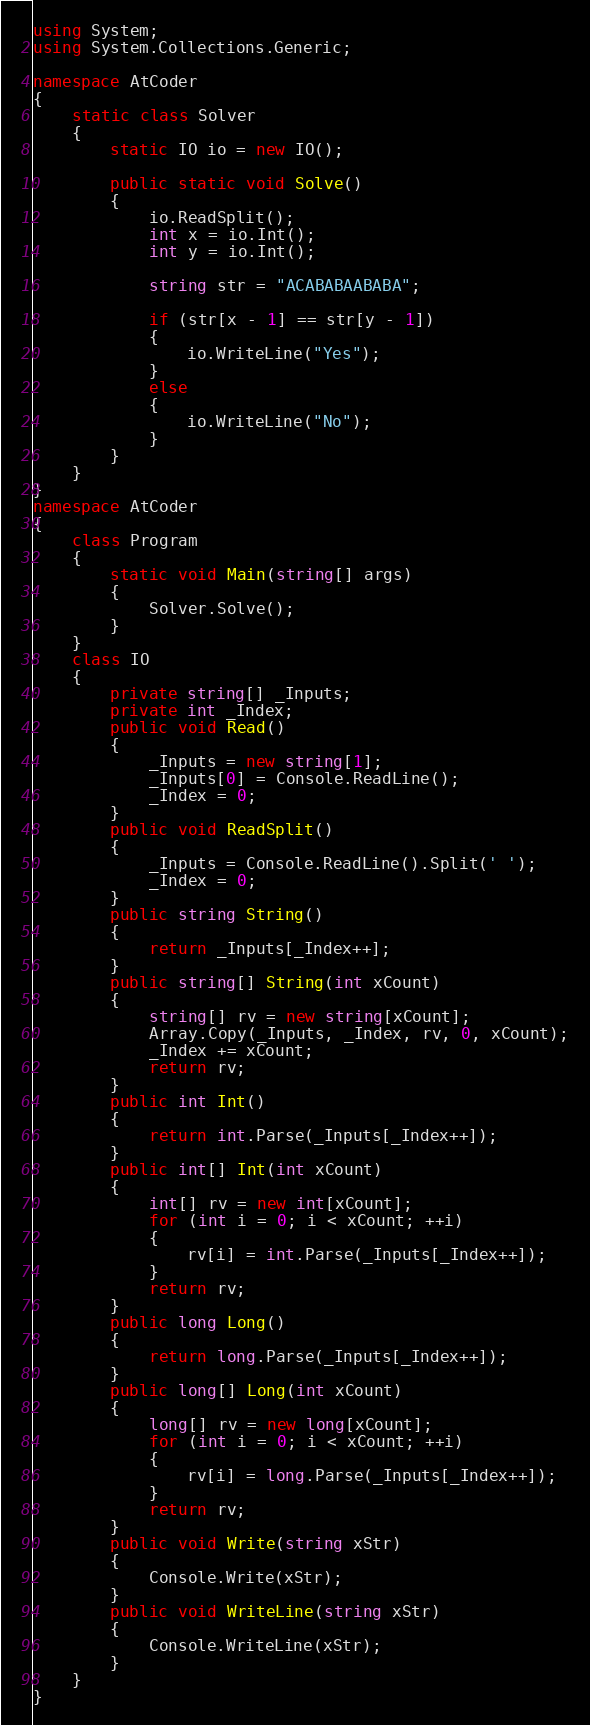<code> <loc_0><loc_0><loc_500><loc_500><_C#_>using System;
using System.Collections.Generic;

namespace AtCoder
{
    static class Solver
    {
        static IO io = new IO();

        public static void Solve()
        {
            io.ReadSplit();
            int x = io.Int();
            int y = io.Int();

            string str = "ACABABAABABA";

            if (str[x - 1] == str[y - 1])
            {
                io.WriteLine("Yes");
            }
            else
            {
                io.WriteLine("No");
            }
        }
    }
}
namespace AtCoder
{
    class Program
    {
        static void Main(string[] args)
        {
            Solver.Solve();
        }
    }
    class IO
    {
        private string[] _Inputs;
        private int _Index;
        public void Read()
        {
            _Inputs = new string[1];
            _Inputs[0] = Console.ReadLine();
            _Index = 0;
        }
        public void ReadSplit()
        {
            _Inputs = Console.ReadLine().Split(' ');
            _Index = 0;
        }
        public string String()
        {
            return _Inputs[_Index++];
        }
        public string[] String(int xCount)
        {
            string[] rv = new string[xCount];
            Array.Copy(_Inputs, _Index, rv, 0, xCount);
            _Index += xCount;
            return rv;
        }
        public int Int()
        {
            return int.Parse(_Inputs[_Index++]);
        }
        public int[] Int(int xCount)
        {
            int[] rv = new int[xCount];
            for (int i = 0; i < xCount; ++i)
            {
                rv[i] = int.Parse(_Inputs[_Index++]);
            }
            return rv;
        }
        public long Long()
        {
            return long.Parse(_Inputs[_Index++]);
        }
        public long[] Long(int xCount)
        {
            long[] rv = new long[xCount];
            for (int i = 0; i < xCount; ++i)
            {
                rv[i] = long.Parse(_Inputs[_Index++]);
            }
            return rv;
        }
        public void Write(string xStr)
        {
            Console.Write(xStr);
        }
        public void WriteLine(string xStr)
        {
            Console.WriteLine(xStr);
        }
    }
}</code> 